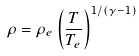<formula> <loc_0><loc_0><loc_500><loc_500>\rho = \rho _ { e } \left ( \frac { T } { T _ { e } } \right ) ^ { 1 / ( \gamma - 1 ) } \\</formula> 